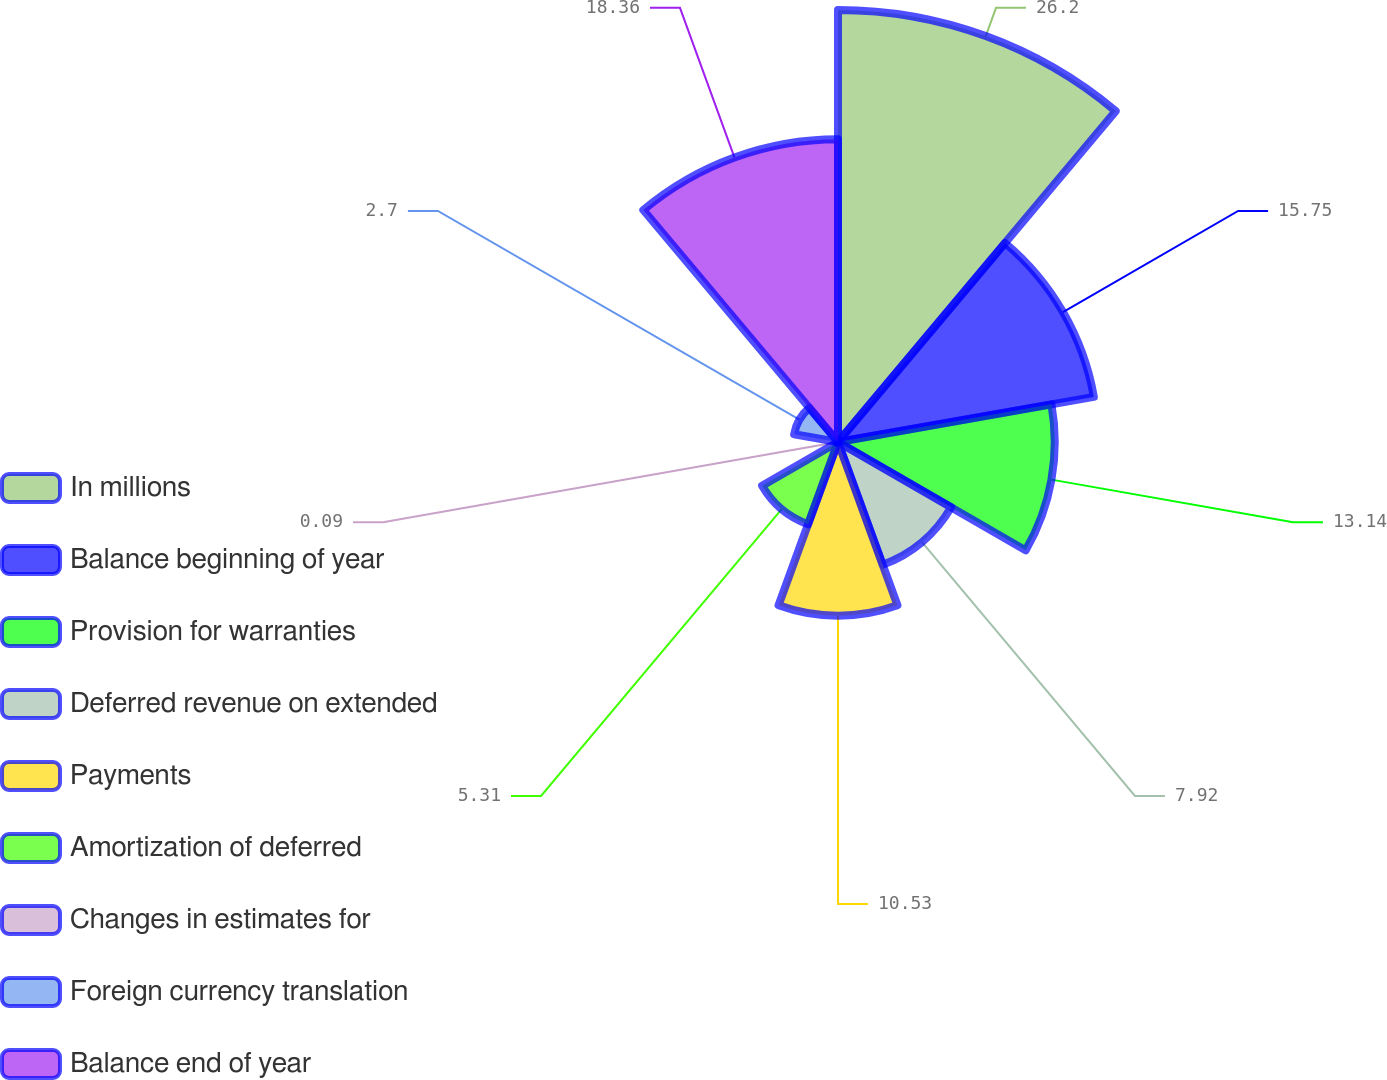Convert chart. <chart><loc_0><loc_0><loc_500><loc_500><pie_chart><fcel>In millions<fcel>Balance beginning of year<fcel>Provision for warranties<fcel>Deferred revenue on extended<fcel>Payments<fcel>Amortization of deferred<fcel>Changes in estimates for<fcel>Foreign currency translation<fcel>Balance end of year<nl><fcel>26.19%<fcel>15.75%<fcel>13.14%<fcel>7.92%<fcel>10.53%<fcel>5.31%<fcel>0.09%<fcel>2.7%<fcel>18.36%<nl></chart> 